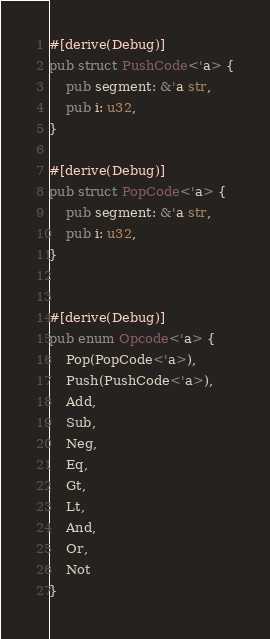<code> <loc_0><loc_0><loc_500><loc_500><_Rust_>#[derive(Debug)]
pub struct PushCode<'a> {
    pub segment: &'a str,
    pub i: u32,
}

#[derive(Debug)]
pub struct PopCode<'a> {
    pub segment: &'a str,
    pub i: u32,
}


#[derive(Debug)]
pub enum Opcode<'a> {
    Pop(PopCode<'a>),
    Push(PushCode<'a>),
    Add,
    Sub,
    Neg,
    Eq,
    Gt,
    Lt,
    And,
    Or,
    Not
}
</code> 